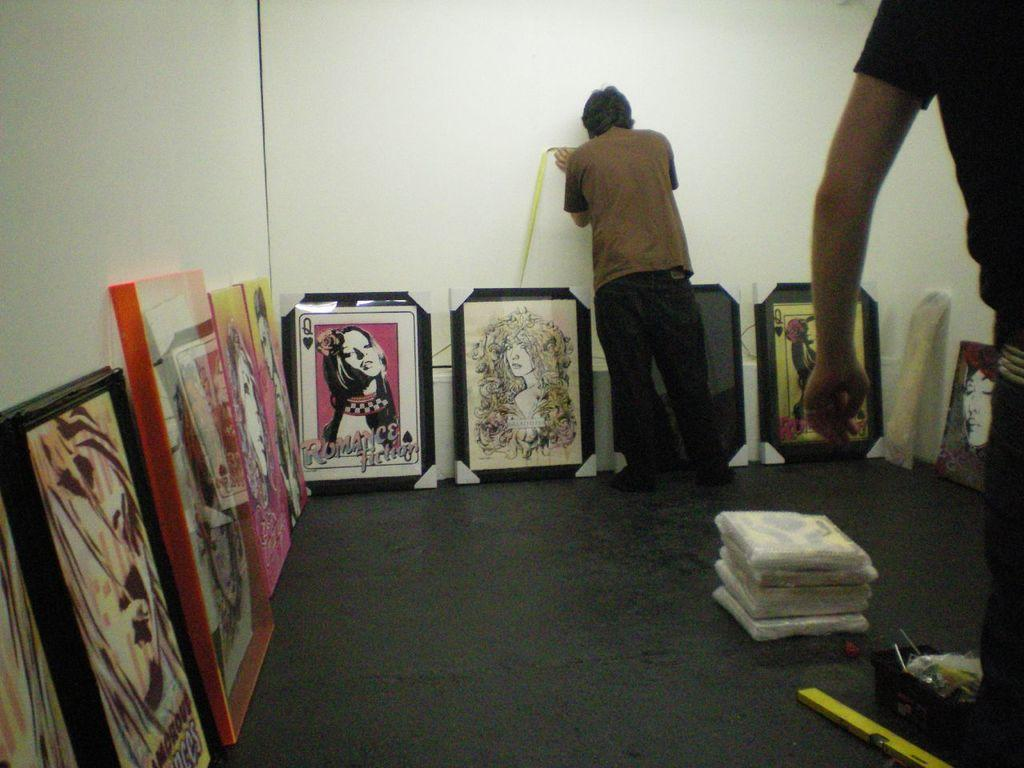<image>
Write a terse but informative summary of the picture. Person in a room with paintings on the ground with one saying "Romance Fiction". 